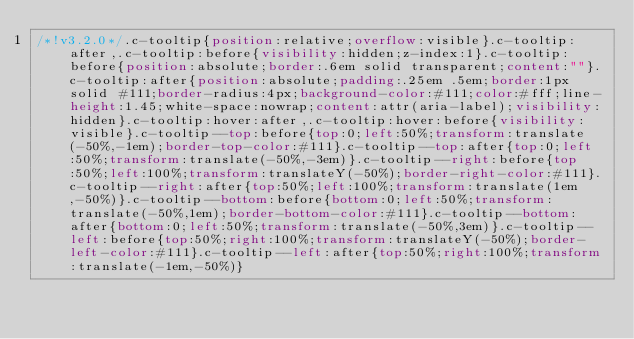<code> <loc_0><loc_0><loc_500><loc_500><_CSS_>/*!v3.2.0*/.c-tooltip{position:relative;overflow:visible}.c-tooltip:after,.c-tooltip:before{visibility:hidden;z-index:1}.c-tooltip:before{position:absolute;border:.6em solid transparent;content:""}.c-tooltip:after{position:absolute;padding:.25em .5em;border:1px solid #111;border-radius:4px;background-color:#111;color:#fff;line-height:1.45;white-space:nowrap;content:attr(aria-label);visibility:hidden}.c-tooltip:hover:after,.c-tooltip:hover:before{visibility:visible}.c-tooltip--top:before{top:0;left:50%;transform:translate(-50%,-1em);border-top-color:#111}.c-tooltip--top:after{top:0;left:50%;transform:translate(-50%,-3em)}.c-tooltip--right:before{top:50%;left:100%;transform:translateY(-50%);border-right-color:#111}.c-tooltip--right:after{top:50%;left:100%;transform:translate(1em,-50%)}.c-tooltip--bottom:before{bottom:0;left:50%;transform:translate(-50%,1em);border-bottom-color:#111}.c-tooltip--bottom:after{bottom:0;left:50%;transform:translate(-50%,3em)}.c-tooltip--left:before{top:50%;right:100%;transform:translateY(-50%);border-left-color:#111}.c-tooltip--left:after{top:50%;right:100%;transform:translate(-1em,-50%)}</code> 